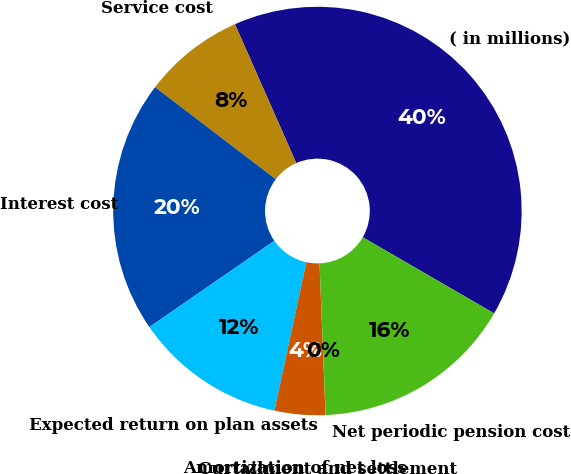<chart> <loc_0><loc_0><loc_500><loc_500><pie_chart><fcel>( in millions)<fcel>Service cost<fcel>Interest cost<fcel>Expected return on plan assets<fcel>Amortization of net loss<fcel>Curtailment and settlement<fcel>Net periodic pension cost<nl><fcel>39.97%<fcel>8.01%<fcel>19.99%<fcel>12.0%<fcel>4.01%<fcel>0.01%<fcel>16.0%<nl></chart> 